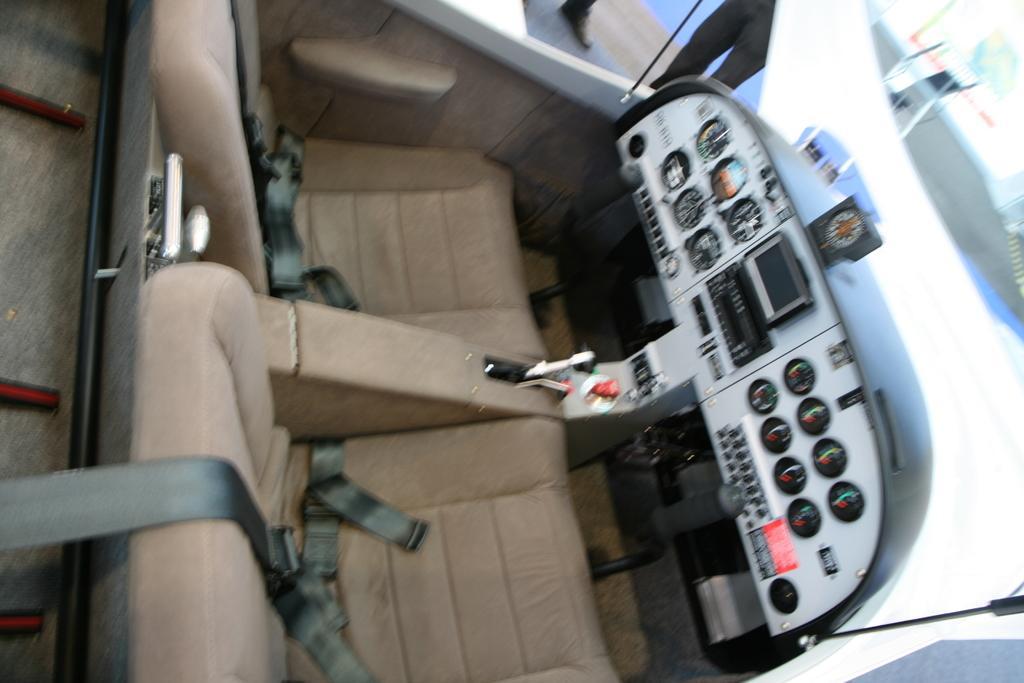Describe this image in one or two sentences. This image is in a vehicle, Where we can see seats, belts, screen and few meters. Through the glass, there are legs on the ground and an object. 